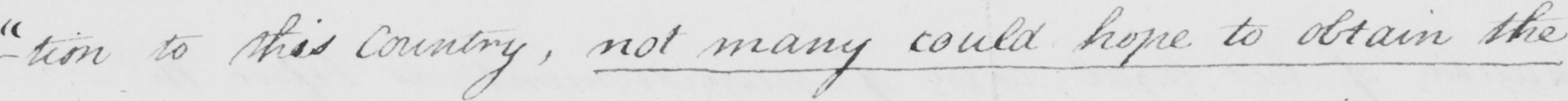Can you tell me what this handwritten text says? - " tion to this Country , not many could hope to obtain the 